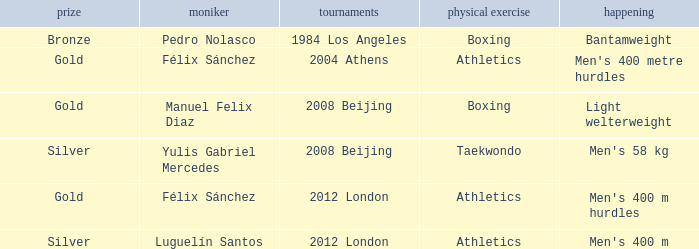Which Games had a Name of manuel felix diaz? 2008 Beijing. 